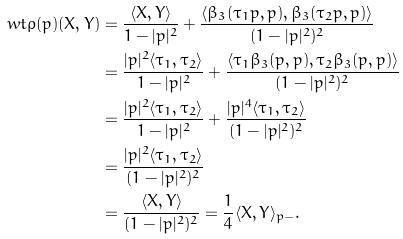Convert formula to latex. <formula><loc_0><loc_0><loc_500><loc_500>\ w t \varrho ( p ) ( X , Y ) & = \frac { \langle X , Y \rangle } { 1 - | p | ^ { 2 } } + \frac { \langle \beta _ { 3 } ( \tau _ { 1 } p , p ) , \beta _ { 3 } ( \tau _ { 2 } p , p ) \rangle } { ( 1 - | p | ^ { 2 } ) ^ { 2 } } \\ & = \frac { | p | ^ { 2 } \langle \tau _ { 1 } , \tau _ { 2 } \rangle } { 1 - | p | ^ { 2 } } + \frac { \langle \tau _ { 1 } \beta _ { 3 } ( p , p ) , \tau _ { 2 } \beta _ { 3 } ( p , p ) \rangle } { ( 1 - | p | ^ { 2 } ) ^ { 2 } } \\ & = \frac { | p | ^ { 2 } \langle \tau _ { 1 } , \tau _ { 2 } \rangle } { 1 - | p | ^ { 2 } } + \frac { | p | ^ { 4 } \langle \tau _ { 1 } , \tau _ { 2 } \rangle } { ( 1 - | p | ^ { 2 } ) ^ { 2 } } \\ & = \frac { | p | ^ { 2 } \langle \tau _ { 1 } , \tau _ { 2 } \rangle } { ( 1 - | p | ^ { 2 } ) ^ { 2 } } \\ & = \frac { \langle X , Y \rangle } { ( 1 - | p | ^ { 2 } ) ^ { 2 } } = \frac { 1 } { 4 } \langle X , Y \rangle _ { p - } .</formula> 